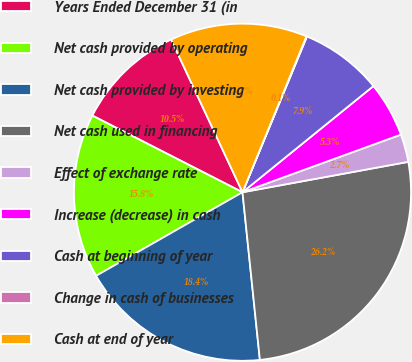Convert chart. <chart><loc_0><loc_0><loc_500><loc_500><pie_chart><fcel>Years Ended December 31 (in<fcel>Net cash provided by operating<fcel>Net cash provided by investing<fcel>Net cash used in financing<fcel>Effect of exchange rate<fcel>Increase (decrease) in cash<fcel>Cash at beginning of year<fcel>Change in cash of businesses<fcel>Cash at end of year<nl><fcel>10.53%<fcel>15.77%<fcel>18.39%<fcel>26.24%<fcel>2.67%<fcel>5.29%<fcel>7.91%<fcel>0.05%<fcel>13.15%<nl></chart> 